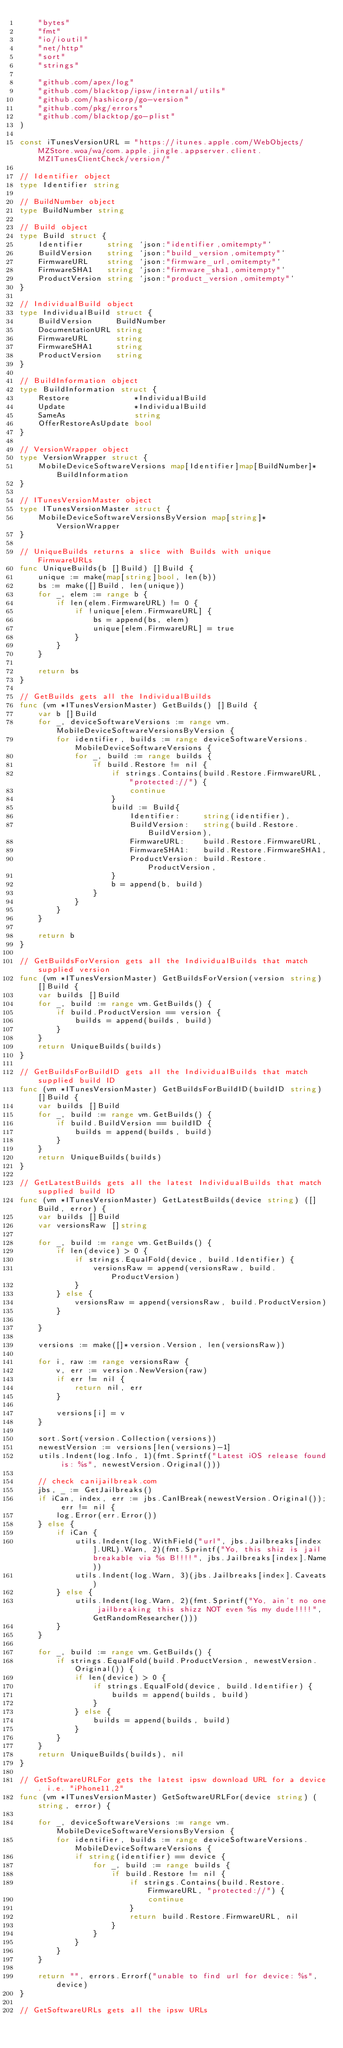Convert code to text. <code><loc_0><loc_0><loc_500><loc_500><_Go_>	"bytes"
	"fmt"
	"io/ioutil"
	"net/http"
	"sort"
	"strings"

	"github.com/apex/log"
	"github.com/blacktop/ipsw/internal/utils"
	"github.com/hashicorp/go-version"
	"github.com/pkg/errors"
	"github.com/blacktop/go-plist"
)

const iTunesVersionURL = "https://itunes.apple.com/WebObjects/MZStore.woa/wa/com.apple.jingle.appserver.client.MZITunesClientCheck/version/"

// Identifier object
type Identifier string

// BuildNumber object
type BuildNumber string

// Build object
type Build struct {
	Identifier     string `json:"identifier,omitempty"`
	BuildVersion   string `json:"build_version,omitempty"`
	FirmwareURL    string `json:"firmware_url,omitempty"`
	FirmwareSHA1   string `json:"firmware_sha1,omitempty"`
	ProductVersion string `json:"product_version,omitempty"`
}

// IndividualBuild object
type IndividualBuild struct {
	BuildVersion     BuildNumber
	DocumentationURL string
	FirmwareURL      string
	FirmwareSHA1     string
	ProductVersion   string
}

// BuildInformation object
type BuildInformation struct {
	Restore              *IndividualBuild
	Update               *IndividualBuild
	SameAs               string
	OfferRestoreAsUpdate bool
}

// VersionWrapper object
type VersionWrapper struct {
	MobileDeviceSoftwareVersions map[Identifier]map[BuildNumber]*BuildInformation
}

// ITunesVersionMaster object
type ITunesVersionMaster struct {
	MobileDeviceSoftwareVersionsByVersion map[string]*VersionWrapper
}

// UniqueBuilds returns a slice with Builds with unique FirmwareURLs
func UniqueBuilds(b []Build) []Build {
	unique := make(map[string]bool, len(b))
	bs := make([]Build, len(unique))
	for _, elem := range b {
		if len(elem.FirmwareURL) != 0 {
			if !unique[elem.FirmwareURL] {
				bs = append(bs, elem)
				unique[elem.FirmwareURL] = true
			}
		}
	}

	return bs
}

// GetBuilds gets all the IndividualBuilds
func (vm *ITunesVersionMaster) GetBuilds() []Build {
	var b []Build
	for _, deviceSoftwareVersions := range vm.MobileDeviceSoftwareVersionsByVersion {
		for identifier, builds := range deviceSoftwareVersions.MobileDeviceSoftwareVersions {
			for _, build := range builds {
				if build.Restore != nil {
					if strings.Contains(build.Restore.FirmwareURL, "protected://") {
						continue
					}
					build := Build{
						Identifier:     string(identifier),
						BuildVersion:   string(build.Restore.BuildVersion),
						FirmwareURL:    build.Restore.FirmwareURL,
						FirmwareSHA1:   build.Restore.FirmwareSHA1,
						ProductVersion: build.Restore.ProductVersion,
					}
					b = append(b, build)
				}
			}
		}
	}

	return b
}

// GetBuildsForVersion gets all the IndividualBuilds that match supplied version
func (vm *ITunesVersionMaster) GetBuildsForVersion(version string) []Build {
	var builds []Build
	for _, build := range vm.GetBuilds() {
		if build.ProductVersion == version {
			builds = append(builds, build)
		}
	}
	return UniqueBuilds(builds)
}

// GetBuildsForBuildID gets all the IndividualBuilds that match supplied build ID
func (vm *ITunesVersionMaster) GetBuildsForBuildID(buildID string) []Build {
	var builds []Build
	for _, build := range vm.GetBuilds() {
		if build.BuildVersion == buildID {
			builds = append(builds, build)
		}
	}
	return UniqueBuilds(builds)
}

// GetLatestBuilds gets all the latest IndividualBuilds that match supplied build ID
func (vm *ITunesVersionMaster) GetLatestBuilds(device string) ([]Build, error) {
	var builds []Build
	var versionsRaw []string

	for _, build := range vm.GetBuilds() {
		if len(device) > 0 {
			if strings.EqualFold(device, build.Identifier) {
				versionsRaw = append(versionsRaw, build.ProductVersion)
			}
		} else {
			versionsRaw = append(versionsRaw, build.ProductVersion)
		}

	}

	versions := make([]*version.Version, len(versionsRaw))

	for i, raw := range versionsRaw {
		v, err := version.NewVersion(raw)
		if err != nil {
			return nil, err
		}

		versions[i] = v
	}

	sort.Sort(version.Collection(versions))
	newestVersion := versions[len(versions)-1]
	utils.Indent(log.Info, 1)(fmt.Sprintf("Latest iOS release found is: %s", newestVersion.Original()))

	// check canijailbreak.com
	jbs, _ := GetJailbreaks()
	if iCan, index, err := jbs.CanIBreak(newestVersion.Original()); err != nil {
		log.Error(err.Error())
	} else {
		if iCan {
			utils.Indent(log.WithField("url", jbs.Jailbreaks[index].URL).Warn, 2)(fmt.Sprintf("Yo, this shiz is jail breakable via %s B!!!!", jbs.Jailbreaks[index].Name))
			utils.Indent(log.Warn, 3)(jbs.Jailbreaks[index].Caveats)
		} else {
			utils.Indent(log.Warn, 2)(fmt.Sprintf("Yo, ain't no one jailbreaking this shizz NOT even %s my dude!!!!", GetRandomResearcher()))
		}
	}

	for _, build := range vm.GetBuilds() {
		if strings.EqualFold(build.ProductVersion, newestVersion.Original()) {
			if len(device) > 0 {
				if strings.EqualFold(device, build.Identifier) {
					builds = append(builds, build)
				}
			} else {
				builds = append(builds, build)
			}
		}
	}
	return UniqueBuilds(builds), nil
}

// GetSoftwareURLFor gets the latest ipsw download URL for a device. i.e. "iPhone11,2"
func (vm *ITunesVersionMaster) GetSoftwareURLFor(device string) (string, error) {

	for _, deviceSoftwareVersions := range vm.MobileDeviceSoftwareVersionsByVersion {
		for identifier, builds := range deviceSoftwareVersions.MobileDeviceSoftwareVersions {
			if string(identifier) == device {
				for _, build := range builds {
					if build.Restore != nil {
						if strings.Contains(build.Restore.FirmwareURL, "protected://") {
							continue
						}
						return build.Restore.FirmwareURL, nil
					}
				}
			}
		}
	}

	return "", errors.Errorf("unable to find url for device: %s", device)
}

// GetSoftwareURLs gets all the ipsw URLs</code> 